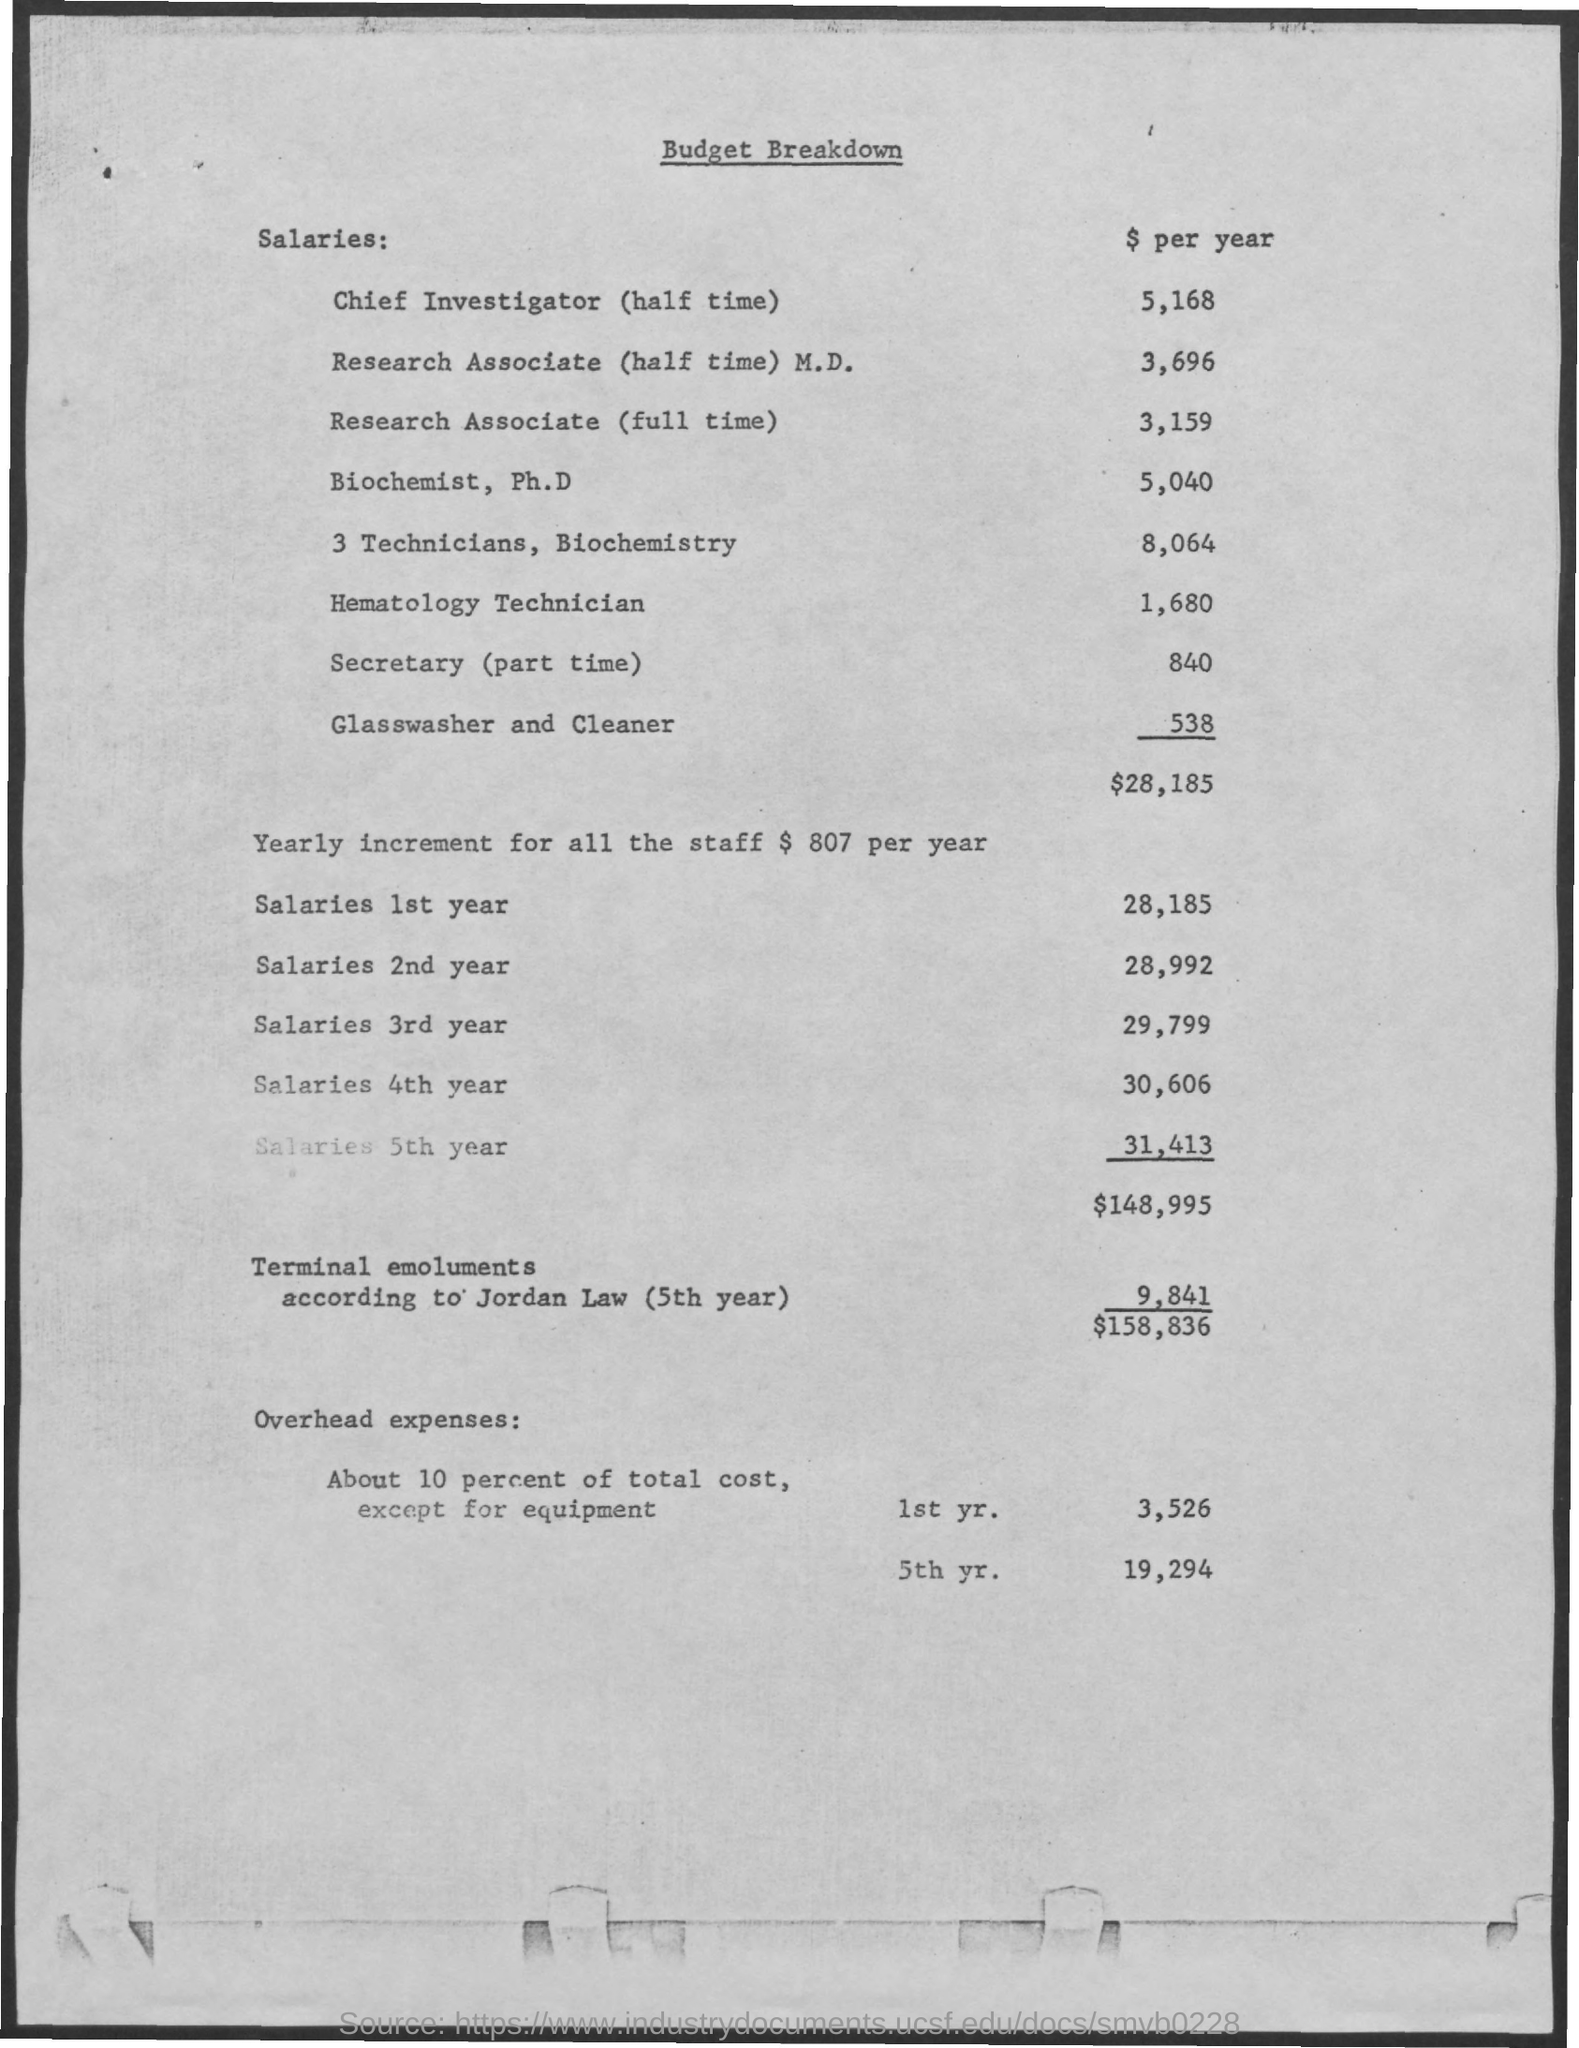What is the document about?
Offer a terse response. Budget Breakdown. What is the salary of secretary ?
Keep it short and to the point. 840$ per year. What is total salaries of 1st year?
Make the answer very short. 28185. What is total of salaries of all 5 years?
Your response must be concise. 148995. 